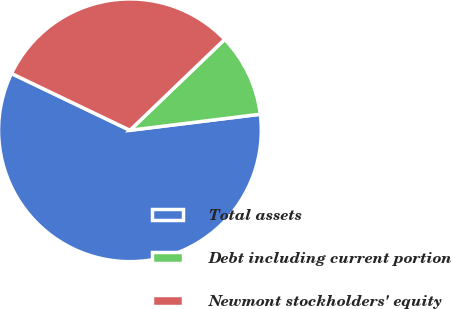<chart> <loc_0><loc_0><loc_500><loc_500><pie_chart><fcel>Total assets<fcel>Debt including current portion<fcel>Newmont stockholders' equity<nl><fcel>59.06%<fcel>10.22%<fcel>30.71%<nl></chart> 